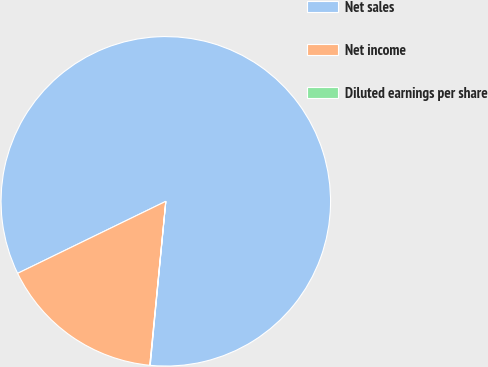Convert chart to OTSL. <chart><loc_0><loc_0><loc_500><loc_500><pie_chart><fcel>Net sales<fcel>Net income<fcel>Diluted earnings per share<nl><fcel>83.71%<fcel>16.25%<fcel>0.04%<nl></chart> 